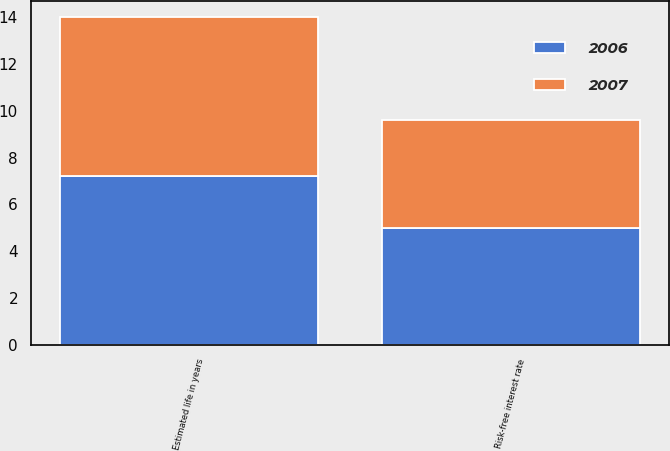Convert chart to OTSL. <chart><loc_0><loc_0><loc_500><loc_500><stacked_bar_chart><ecel><fcel>Risk-free interest rate<fcel>Estimated life in years<nl><fcel>2007<fcel>4.6<fcel>6.8<nl><fcel>2006<fcel>5<fcel>7.2<nl></chart> 